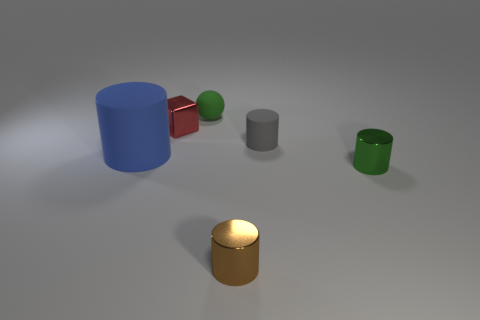Subtract all small gray matte cylinders. How many cylinders are left? 3 Add 3 large cyan matte cylinders. How many objects exist? 9 Subtract all gray cylinders. How many cylinders are left? 3 Subtract all yellow cylinders. Subtract all cyan cubes. How many cylinders are left? 4 Add 2 gray rubber things. How many gray rubber things exist? 3 Subtract 0 purple cylinders. How many objects are left? 6 Subtract all cylinders. How many objects are left? 2 Subtract all large red objects. Subtract all red metallic objects. How many objects are left? 5 Add 2 tiny gray rubber things. How many tiny gray rubber things are left? 3 